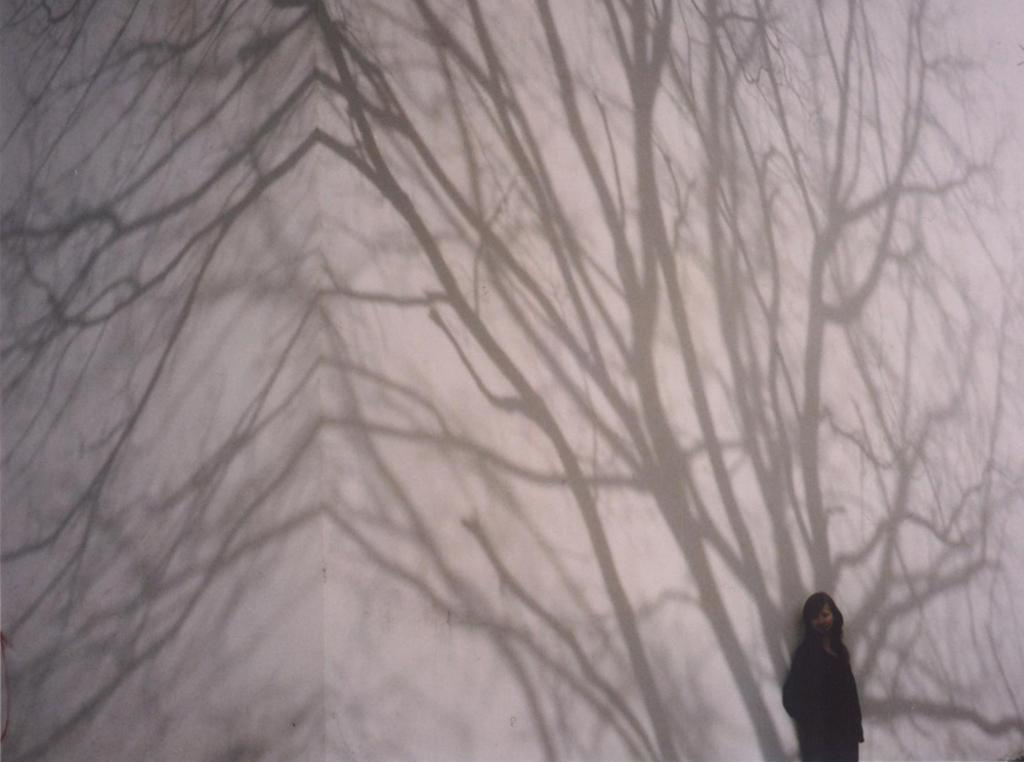What can be seen on the wall in the image? There are shadows on the wall in the image. Can you describe the person in the image? There is a person in the bottom right of the image. How many ducks are sitting on the person's desk in the image? There are no ducks present in the image. What is the title of the document the person is working on in the image? There is no document or title visible in the image. 